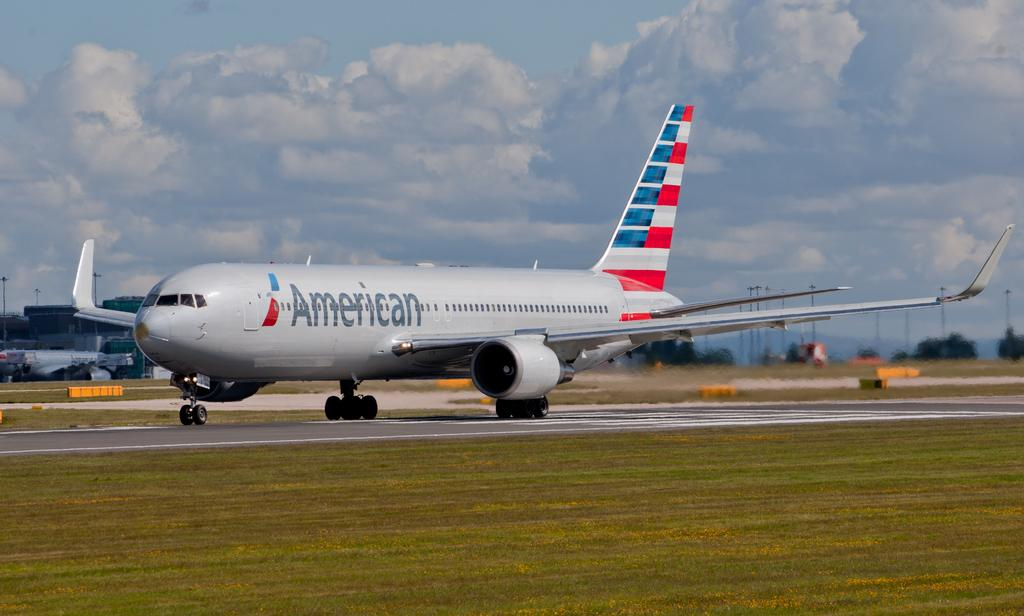Provide a one-sentence caption for the provided image. A large commercial American airlines plane is on a runway. 